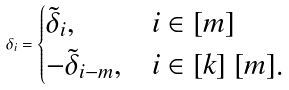Convert formula to latex. <formula><loc_0><loc_0><loc_500><loc_500>\delta _ { i } = \begin{cases} \tilde { \delta } _ { i } , & i \in [ m ] \\ - \tilde { \delta } _ { i - m } , & i \in [ k ] \ [ m ] . \end{cases}</formula> 